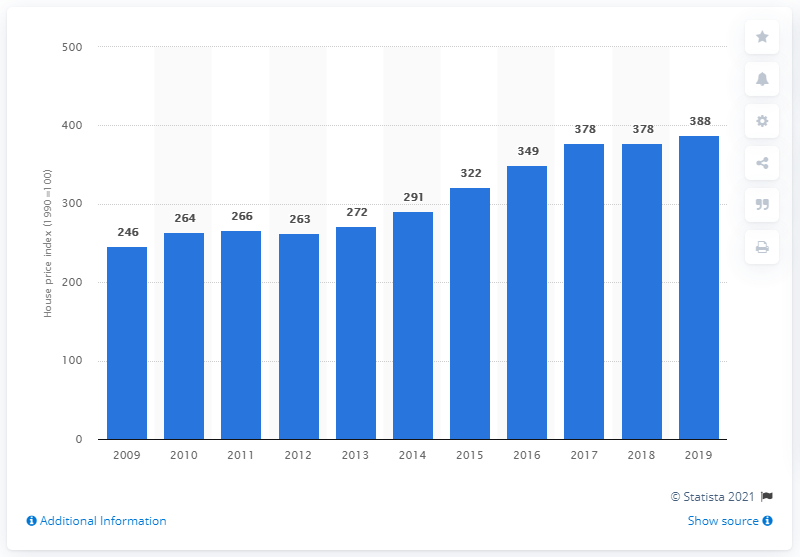Outline some significant characteristics in this image. In 2009, the real estate price index in Sweden was 246. 